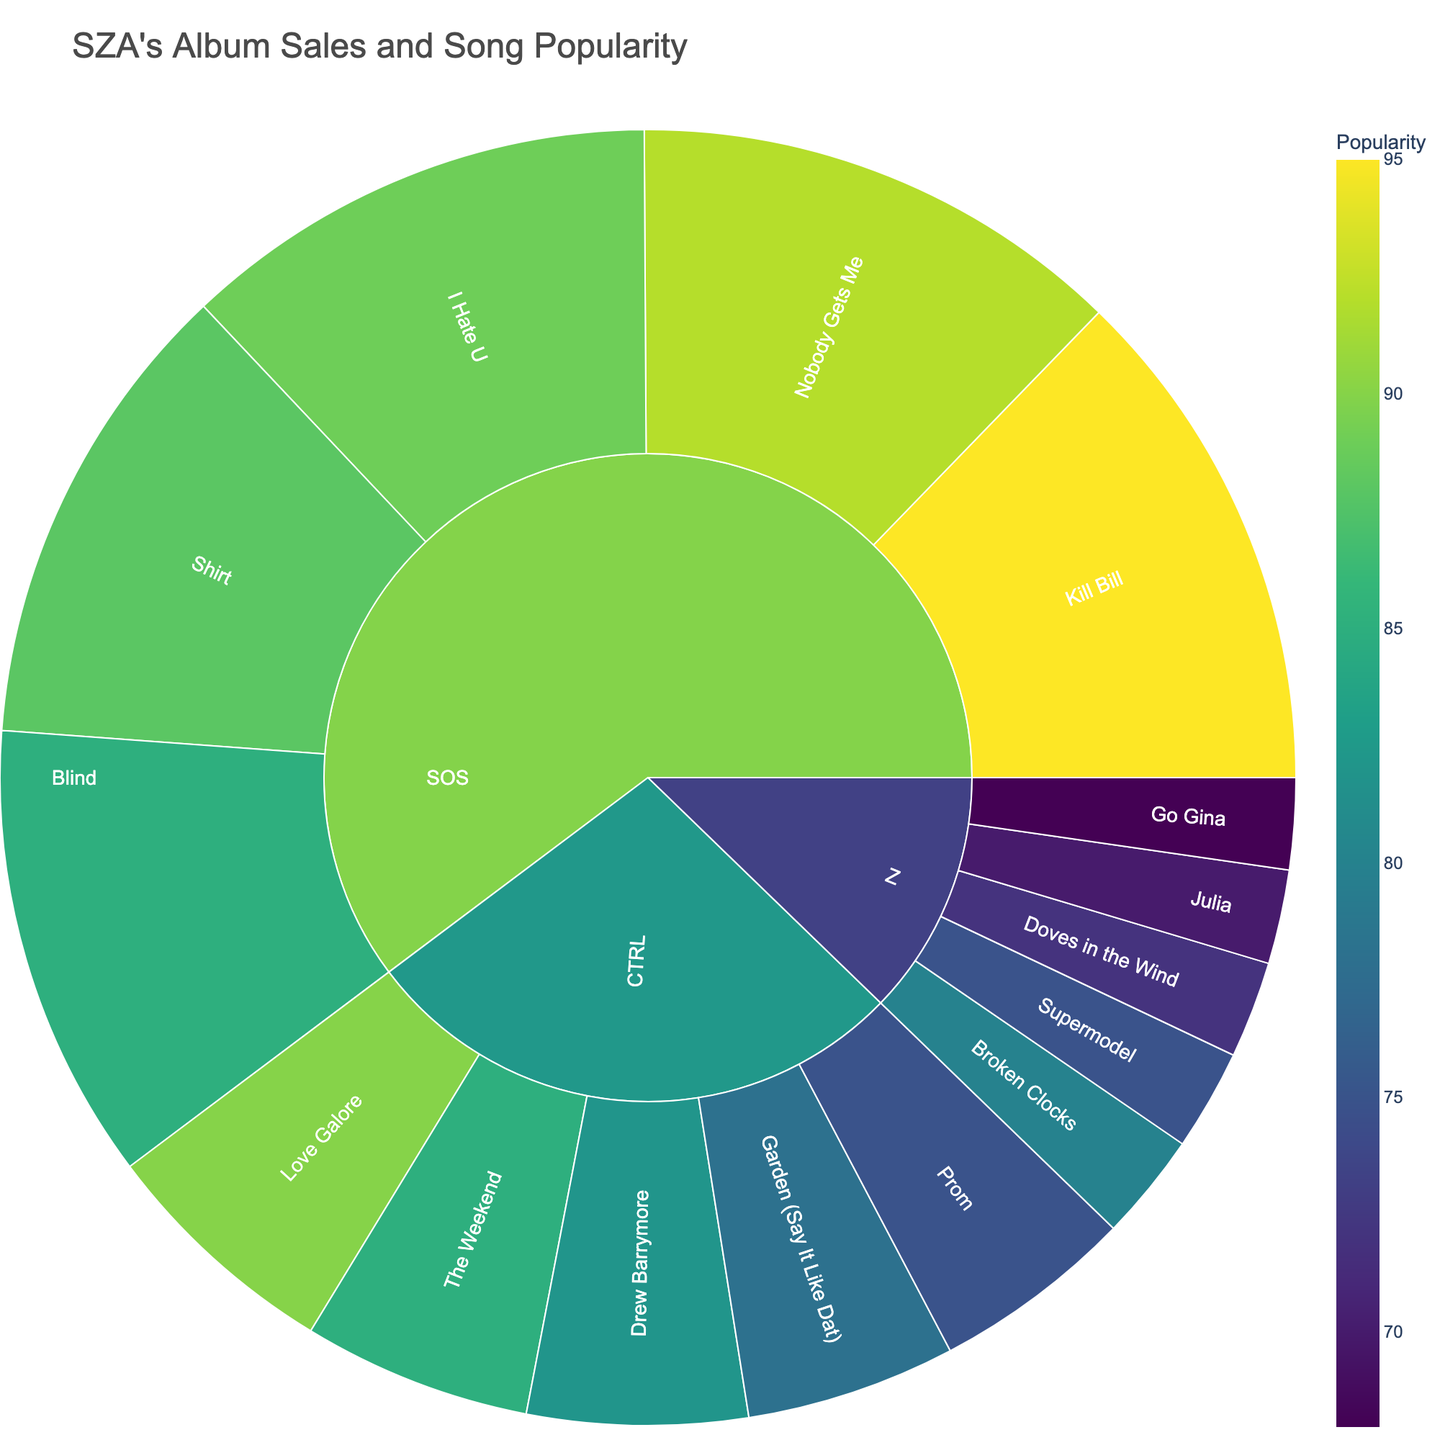What’s the title of the plot? The title of the plot is usually placed at the top of the figure. In this case, the plot’s title reads "SZA's Album Sales and Song Popularity".
Answer: SZA's Album Sales and Song Popularity Which album has the highest sales value? The outer rings of the sunburst plot show the subdivisions of each album's breakdown. In this figure, the album SOS has the highest sales value, represented by the larger sections of the plot.
Answer: SOS What’s the sales value for the "CTRL" album? The sunburst plot usually allows hovering over each section to see details. From the data provided, we can see that the "CTRL" album has a sales value of 500,000.
Answer: 500,000 Which song has the highest popularity rating in the "SOS" album? By examining the subdivisions under the "SOS" album, we identify the segment with the highest popularity. "Kill Bill" has a popularity rating of 95, which is the highest in the "SOS" album.
Answer: Kill Bill How does the popularity of "Drew Barrymore" compare to "Supermodel"? By checking the segments of both songs from the sunburst plot, "Drew Barrymore" has a popularity of 82, and "Supermodel" has a popularity of 75. Comparing the two, "Drew Barrymore" has a higher popularity.
Answer: Drew Barrymore is more popular If we combine the popularity ratings of "Blind" and "I Hate U", what do we get? The popularity rating of "Blind" is 85, and "I Hate U" is 89. Adding them together, we get 85 + 89 = 174.
Answer: 174 Are there more highly popular songs (popularity of 80 or above) in "CTRL" or "SOS"? From the segments, "CTRL" has 3 songs with a popularity of 80 or above ("The Weekend", "Garden (Say It Like Dat)", and "Drew Barrymore"), while "SOS" has 5 ("Kill Bill", "Shirt", "Nobody Gets Me", "Blind", and "I Hate U"). "SOS" has more highly popular songs.
Answer: SOS Which album has the least popular song? Within the sunburst, the least popular song is in the album "Z", which is "Go Gina" with a popularity rating of 68.
Answer: Z Considering only the 'CTRL' album, what is the average popularity of its songs? The popularity values of 'CTRL' songs are 85, 78, 82, 75, and 90. Summing them gives 410, and dividing by the number of songs (5), we get an average of 82.
Answer: 82 